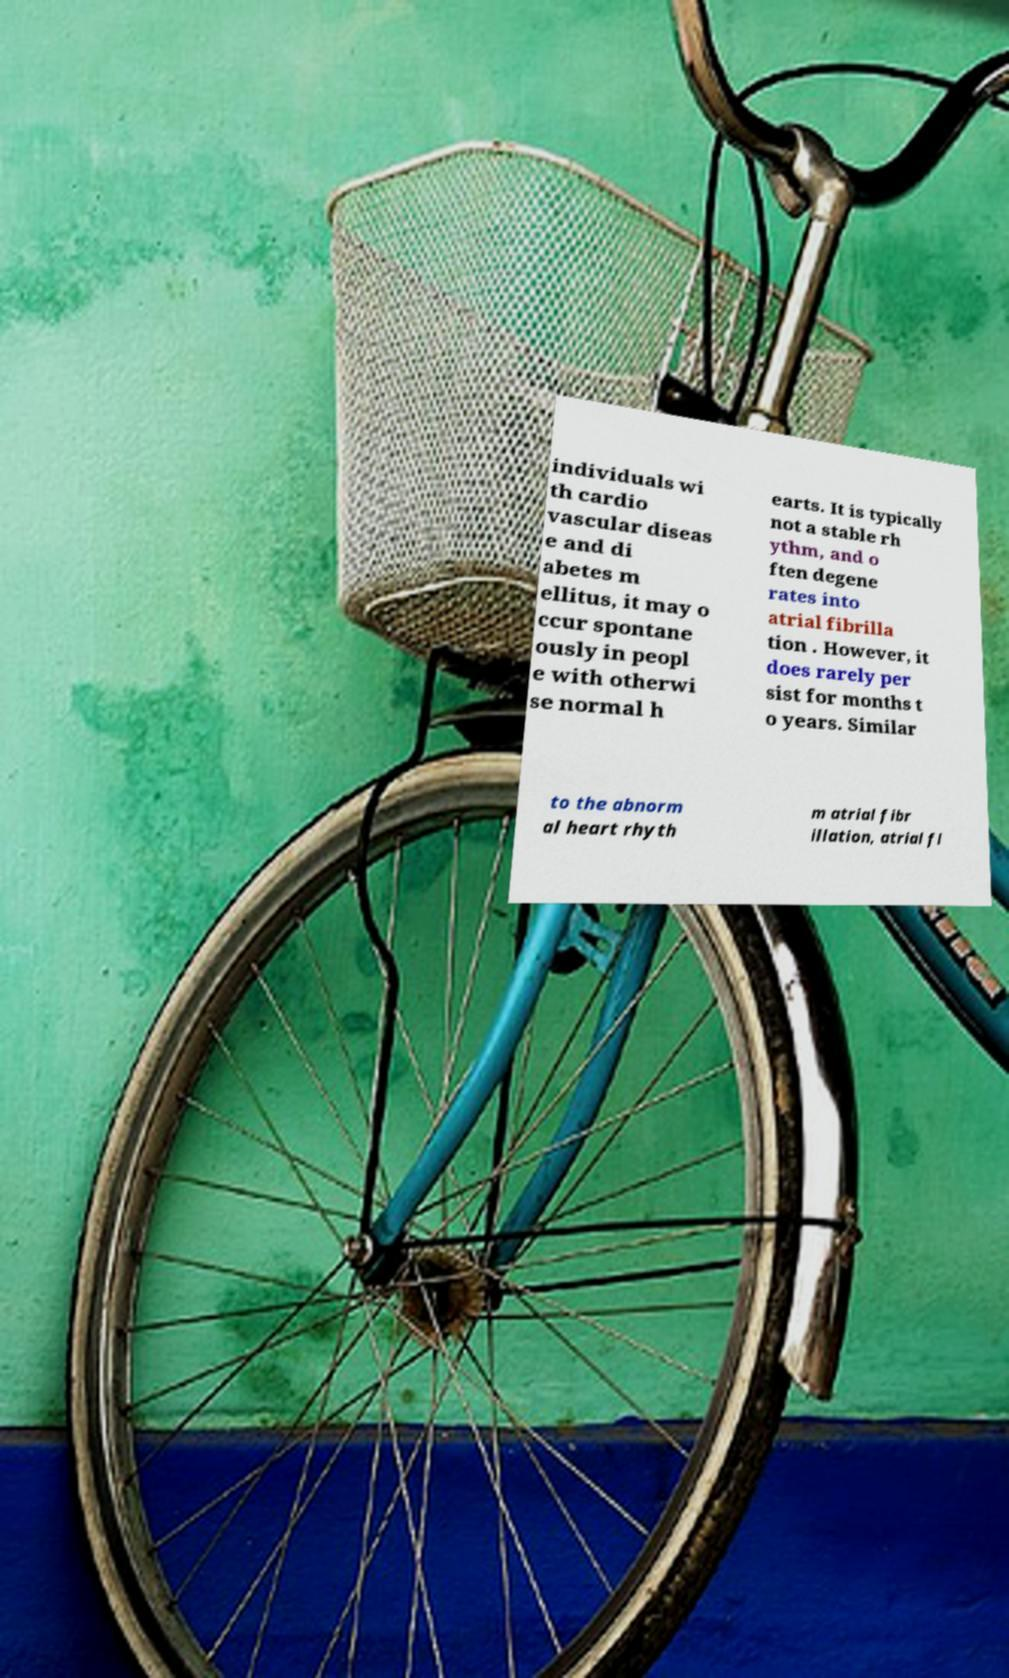Can you accurately transcribe the text from the provided image for me? individuals wi th cardio vascular diseas e and di abetes m ellitus, it may o ccur spontane ously in peopl e with otherwi se normal h earts. It is typically not a stable rh ythm, and o ften degene rates into atrial fibrilla tion . However, it does rarely per sist for months t o years. Similar to the abnorm al heart rhyth m atrial fibr illation, atrial fl 